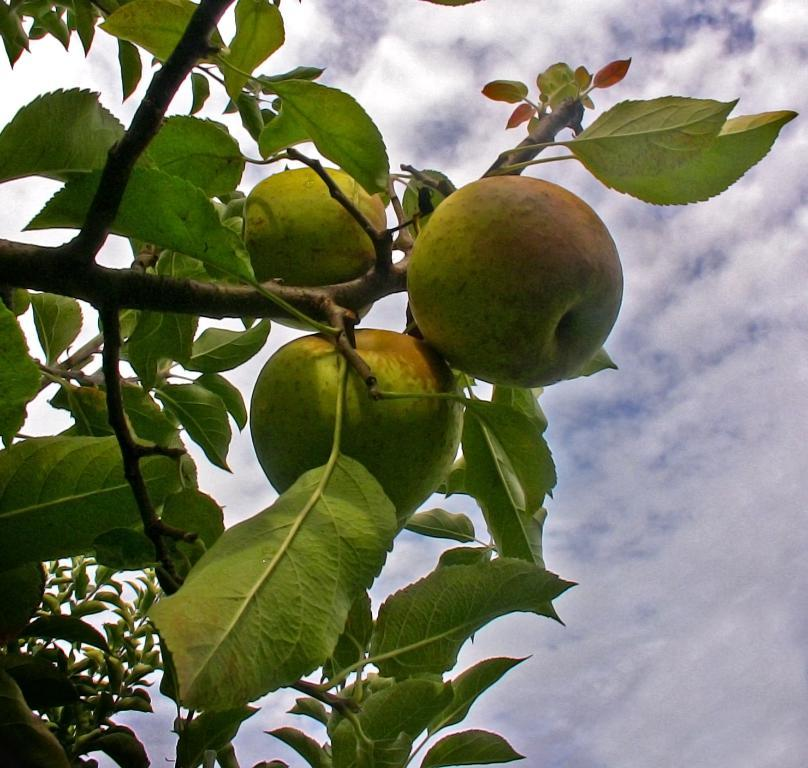What type of trees are present in the image? There are apple trees in the image. What can be found on the apple trees? There are apples in the image. What can be seen in the background of the image? The sky is visible in the background of the image. How many times do the people in the image say good-bye to each other? There are no people present in the image, so it is not possible to determine how many times they say good-bye to each other. 